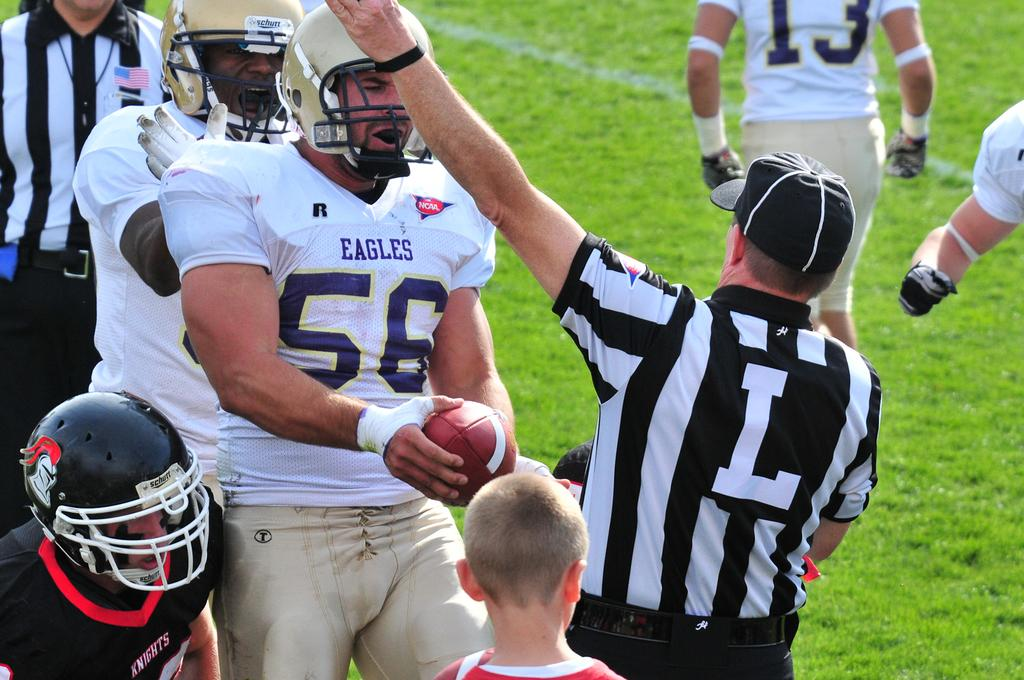How many people are in the image? There is a group of persons in the image. What can be seen in the background of the image? There is grass visible in the background of the image. What is the person in the foreground holding? There is a person holding a ball in the foreground of the image. What type of mint is growing in the image? There is no mint visible in the image; only grass is mentioned in the background. 